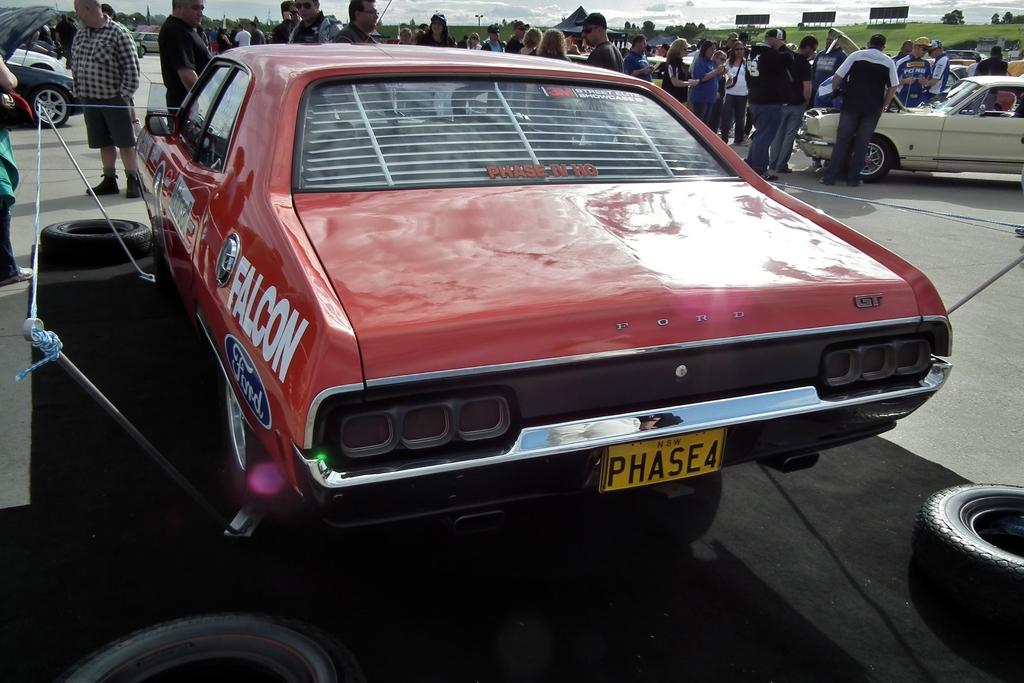Who or what can be seen in the image? There are people in the image. What else is present in the image besides people? There are vehicles, tires, trees, grass, boards, and poles in the image. What can be seen in the background of the image? The sky is visible in the background of the image, and clouds are present in the sky. Can you see the ocean in the image? No, the ocean is not present in the image. What type of bait is being used by the people in the image? There is no indication of fishing or bait in the image; it features people, vehicles, and other objects in a setting with trees, grass, and poles. 